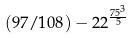<formula> <loc_0><loc_0><loc_500><loc_500>( 9 7 / 1 0 8 ) - 2 2 ^ { \frac { 7 5 ^ { 3 } } { 5 } }</formula> 